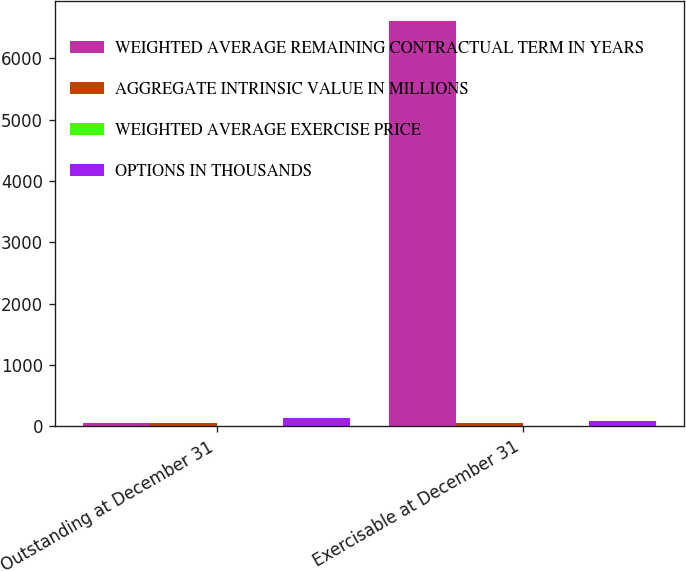<chart> <loc_0><loc_0><loc_500><loc_500><stacked_bar_chart><ecel><fcel>Outstanding at December 31<fcel>Exercisable at December 31<nl><fcel>WEIGHTED AVERAGE REMAINING CONTRACTUAL TERM IN YEARS<fcel>60.78<fcel>6609<nl><fcel>AGGREGATE INTRINSIC VALUE IN MILLIONS<fcel>60.78<fcel>57.91<nl><fcel>WEIGHTED AVERAGE EXERCISE PRICE<fcel>6.63<fcel>5.51<nl><fcel>OPTIONS IN THOUSANDS<fcel>131<fcel>85<nl></chart> 